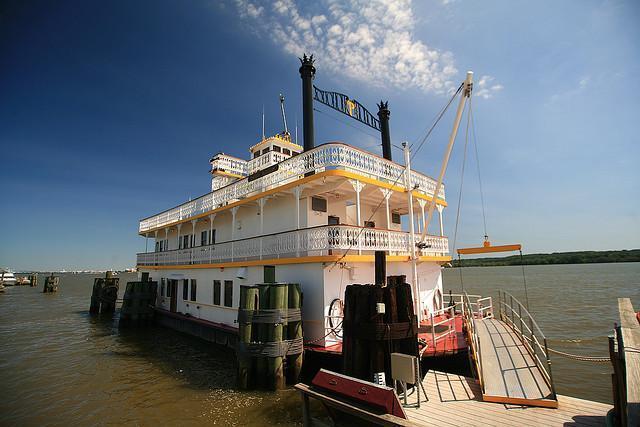How many stories is the boat?
Give a very brief answer. 2. 